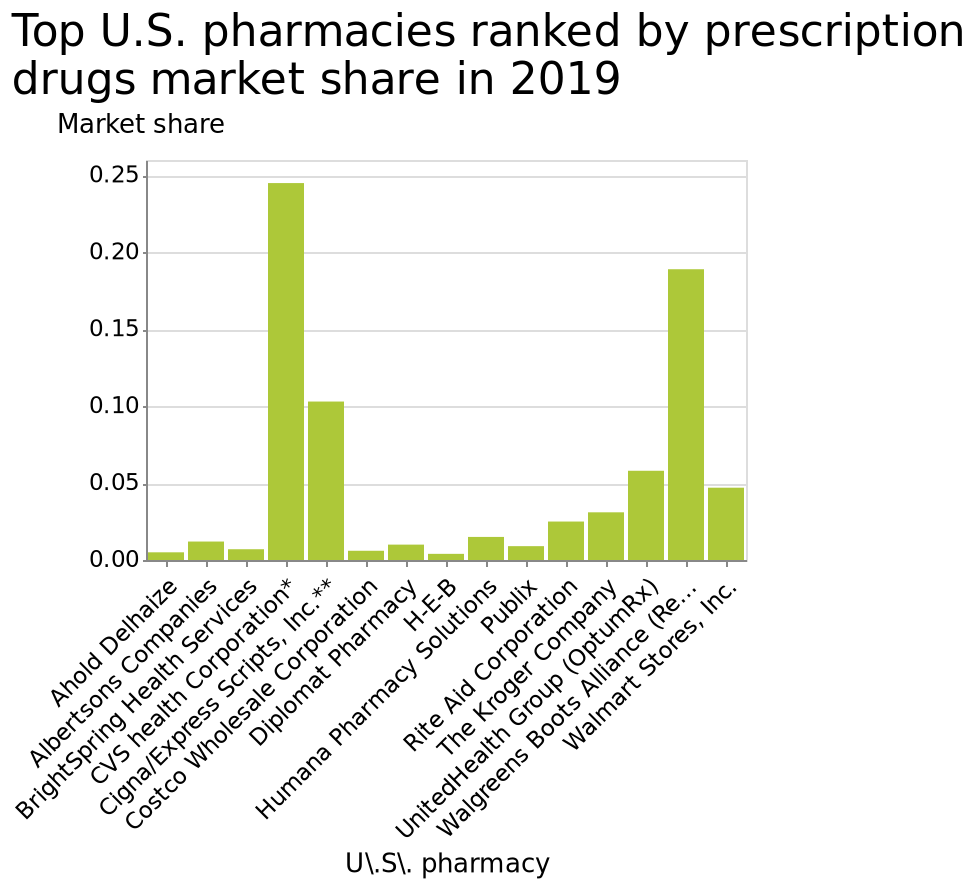<image>
Which company has the lowest prescription drug market share?  HEB What was the year in which the market share data was collected? The market share data was collected in 2019. Can you name the two companies mentioned in the figure? CVS and HEB. Offer a thorough analysis of the image. CVS has the most prescription drug market share. HEB has the least amount of prescription drug market share. Does CVS have the least amount of prescription drug market share and HEB has the most prescription drug market share? No.CVS has the most prescription drug market share. HEB has the least amount of prescription drug market share. 